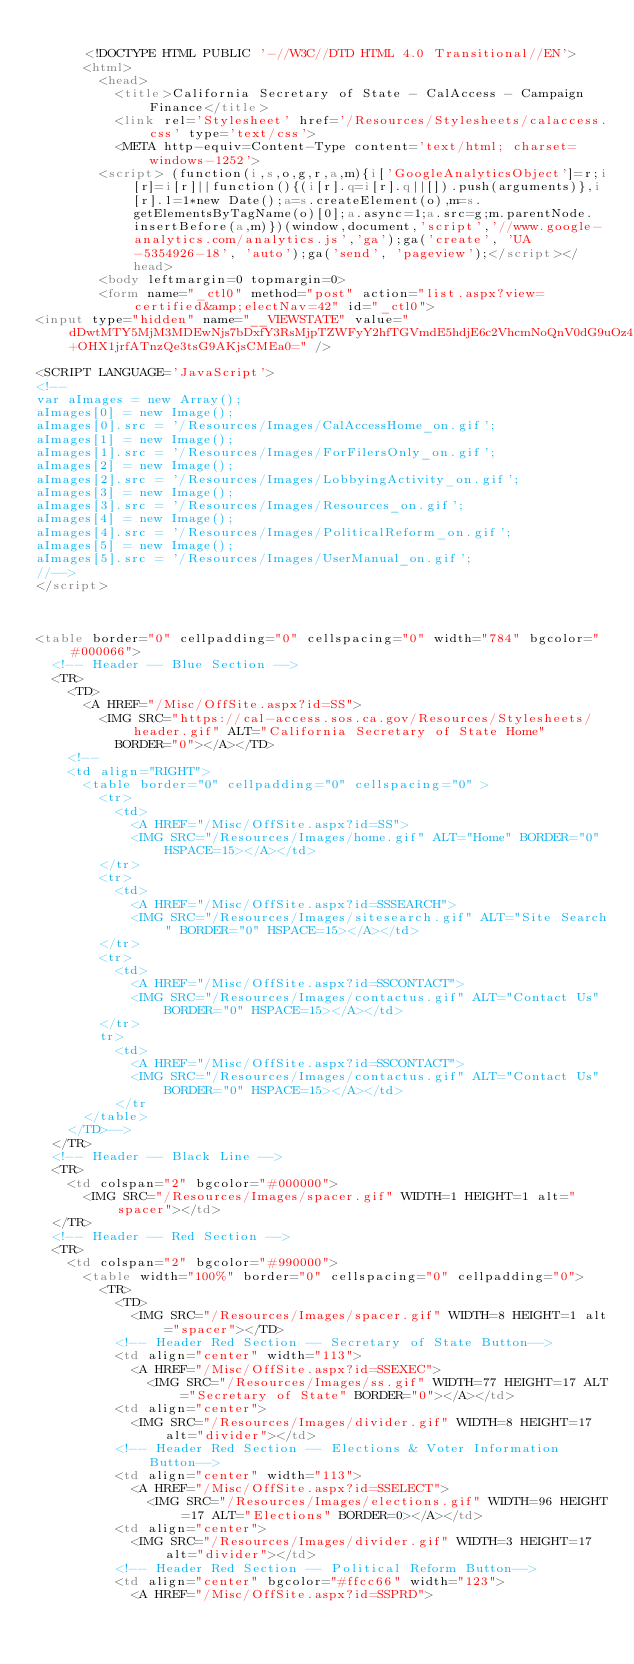<code> <loc_0><loc_0><loc_500><loc_500><_HTML_>
			<!DOCTYPE HTML PUBLIC '-//W3C//DTD HTML 4.0 Transitional//EN'>
			<html>
				<head>
					<title>California Secretary of State - CalAccess - Campaign Finance</title> 
					<link rel='Stylesheet' href='/Resources/Stylesheets/calaccess.css' type='text/css'>
					<META http-equiv=Content-Type content='text/html; charset=windows-1252'>
				<script> (function(i,s,o,g,r,a,m){i['GoogleAnalyticsObject']=r;i[r]=i[r]||function(){(i[r].q=i[r].q||[]).push(arguments)},i[r].l=1*new Date();a=s.createElement(o),m=s.getElementsByTagName(o)[0];a.async=1;a.src=g;m.parentNode.insertBefore(a,m)})(window,document,'script','//www.google-analytics.com/analytics.js','ga');ga('create', 'UA-5354926-18', 'auto');ga('send', 'pageview');</script></head>
				<body leftmargin=0 topmargin=0>
				<form name="_ctl0" method="post" action="list.aspx?view=certified&amp;electNav=42" id="_ctl0">
<input type="hidden" name="__VIEWSTATE" value="dDwtMTY5MjM3MDEwNjs7bDxfY3RsMjpTZWFyY2hfTGVmdE5hdjE6c2VhcmNoQnV0dG9uOz4+OHX1jrfATnzQe3tsG9AKjsCMEa0=" />
	
<SCRIPT LANGUAGE='JavaScript'>
<!--
var aImages = new Array();
aImages[0] = new Image();
aImages[0].src = '/Resources/Images/CalAccessHome_on.gif';
aImages[1] = new Image();
aImages[1].src = '/Resources/Images/ForFilersOnly_on.gif';
aImages[2] = new Image();
aImages[2].src = '/Resources/Images/LobbyingActivity_on.gif';
aImages[3] = new Image();
aImages[3].src = '/Resources/Images/Resources_on.gif';
aImages[4] = new Image();
aImages[4].src = '/Resources/Images/PoliticalReform_on.gif';
aImages[5] = new Image();
aImages[5].src = '/Resources/Images/UserManual_on.gif';
//-->
</script>



<table border="0" cellpadding="0" cellspacing="0" width="784" bgcolor="#000066">
	<!-- Header -- Blue Section -->
	<TR>
		<TD>
			<A HREF="/Misc/OffSite.aspx?id=SS">
				<IMG SRC="https://cal-access.sos.ca.gov/Resources/Stylesheets/header.gif" ALT="California Secretary of State Home"
					BORDER="0"></A></TD>
		<!-- 		
		<td align="RIGHT">
			<table border="0" cellpadding="0" cellspacing="0" >
				<tr>
					<td>
						<A HREF="/Misc/OffSite.aspx?id=SS">
						<IMG SRC="/Resources/Images/home.gif" ALT="Home" BORDER="0" HSPACE=15></A></td>
				</tr>
				<tr>
					<td>
						<A HREF="/Misc/OffSite.aspx?id=SSSEARCH">
						<IMG SRC="/Resources/Images/sitesearch.gif" ALT="Site Search" BORDER="0" HSPACE=15></A></td>
				</tr>
				<tr>
					<td>
						<A HREF="/Misc/OffSite.aspx?id=SSCONTACT">
						<IMG SRC="/Resources/Images/contactus.gif" ALT="Contact Us" BORDER="0" HSPACE=15></A></td>
				</tr>
				tr>
					<td>
						<A HREF="/Misc/OffSite.aspx?id=SSCONTACT">
						<IMG SRC="/Resources/Images/contactus.gif" ALT="Contact Us" BORDER="0" HSPACE=15></A></td>
					</tr 
			</table>
		</TD>-->
	</TR>
	<!-- Header -- Black Line -->
	<TR>
		<td colspan="2" bgcolor="#000000">
			<IMG SRC="/Resources/Images/spacer.gif" WIDTH=1 HEIGHT=1 alt="spacer"></td>
	</TR>
	<!-- Header -- Red Section -->
	<TR>
		<td colspan="2" bgcolor="#990000">
			<table width="100%" border="0" cellspacing="0" cellpadding="0">
				<TR>
					<TD>
						<IMG SRC="/Resources/Images/spacer.gif" WIDTH=8 HEIGHT=1 alt="spacer"></TD>
					<!-- Header Red Section -- Secretary of State Button-->
					<td align="center" width="113">
						<A HREF="/Misc/OffSite.aspx?id=SSEXEC">
							<IMG SRC="/Resources/Images/ss.gif" WIDTH=77 HEIGHT=17 ALT="Secretary of State" BORDER="0"></A></td>
					<td align="center">
						<IMG SRC="/Resources/Images/divider.gif" WIDTH=8 HEIGHT=17 alt="divider"></td>
					<!-- Header Red Section -- Elections & Voter Information Button-->
					<td align="center" width="113">
						<A HREF="/Misc/OffSite.aspx?id=SSELECT">
							<IMG SRC="/Resources/Images/elections.gif" WIDTH=96 HEIGHT=17 ALT="Elections" BORDER=0></A></td>
					<td align="center">
						<IMG SRC="/Resources/Images/divider.gif" WIDTH=3 HEIGHT=17 alt="divider"></td>
					<!-- Header Red Section -- Political Reform Button-->
					<td align="center" bgcolor="#ffcc66" width="123">
						<A HREF="/Misc/OffSite.aspx?id=SSPRD"></code> 